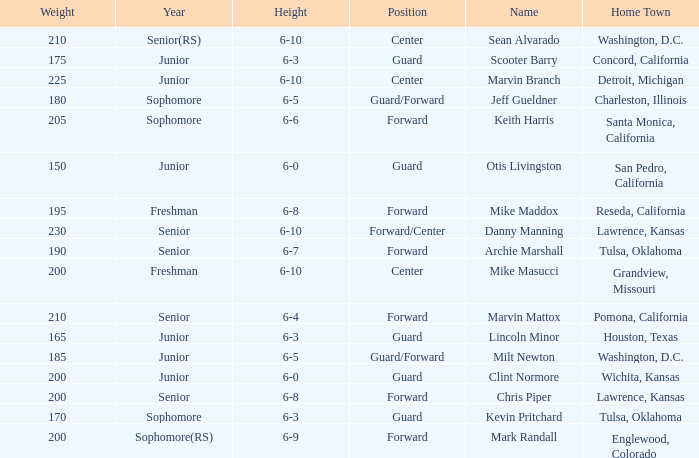Can you tell me the average Weight that has Height of 6-9? 200.0. 